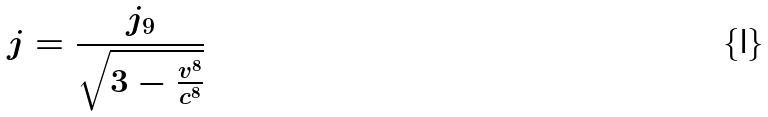Convert formula to latex. <formula><loc_0><loc_0><loc_500><loc_500>j = \frac { j _ { 9 } } { \sqrt { 3 - \frac { v ^ { 8 } } { c ^ { 8 } } } }</formula> 